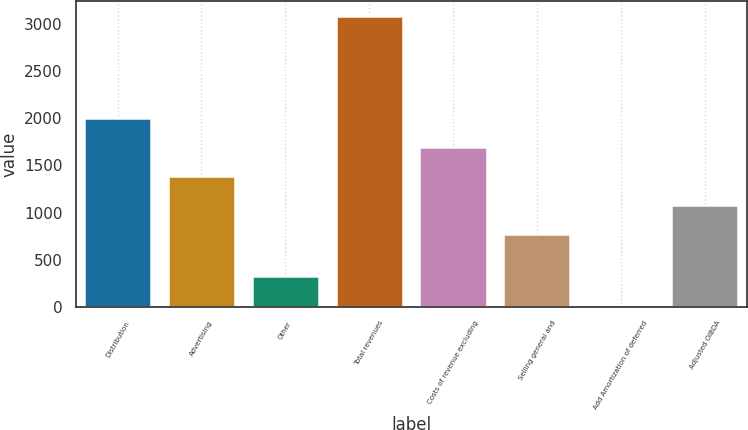Convert chart. <chart><loc_0><loc_0><loc_500><loc_500><bar_chart><fcel>Distribution<fcel>Advertising<fcel>Other<fcel>Total revenues<fcel>Costs of revenue excluding<fcel>Selling general and<fcel>Add Amortization of deferred<fcel>Adjusted OIBDA<nl><fcel>2002.4<fcel>1387.2<fcel>323.6<fcel>3092<fcel>1694.8<fcel>772<fcel>16<fcel>1079.6<nl></chart> 